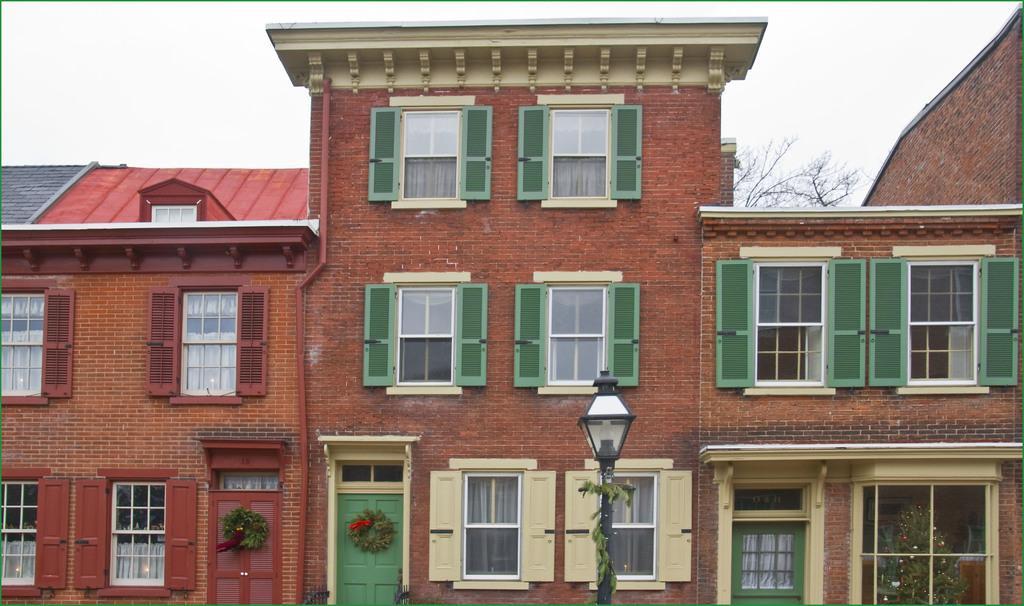How would you summarize this image in a sentence or two? In the image there is a building with many windows and door and a light pole in the middle and above its sky. 